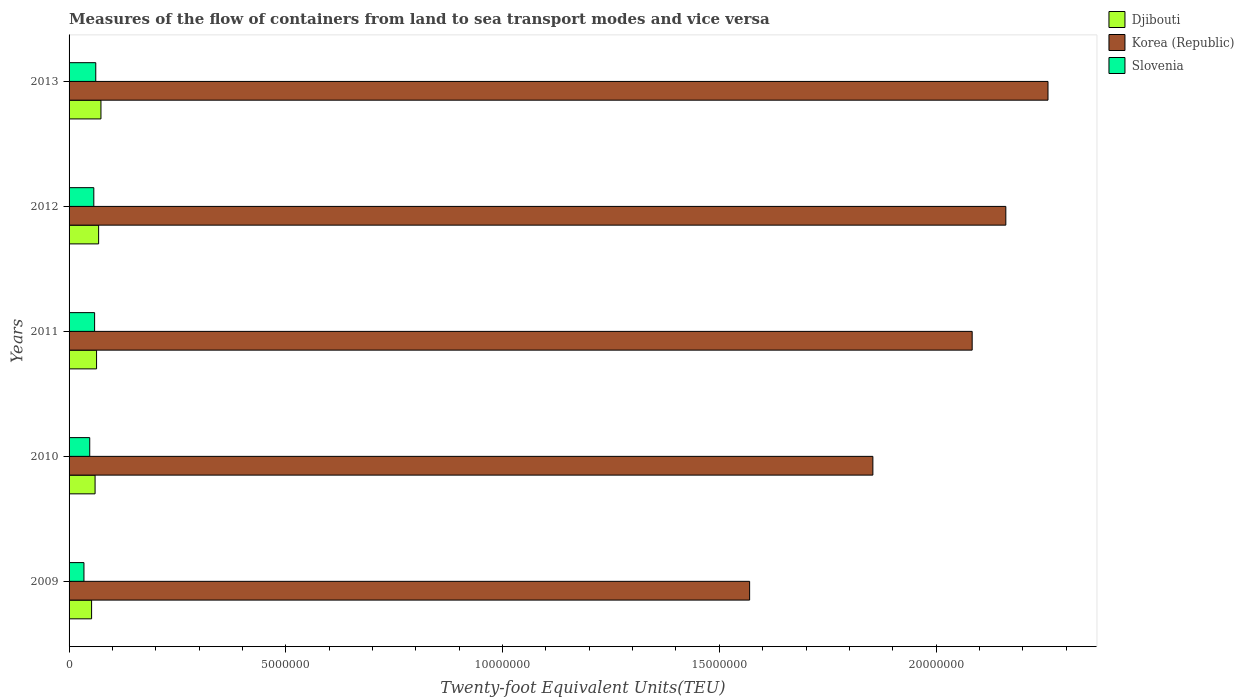How many different coloured bars are there?
Offer a very short reply. 3. How many groups of bars are there?
Your answer should be very brief. 5. How many bars are there on the 4th tick from the top?
Your answer should be compact. 3. How many bars are there on the 3rd tick from the bottom?
Your answer should be very brief. 3. What is the label of the 5th group of bars from the top?
Make the answer very short. 2009. What is the container port traffic in Djibouti in 2010?
Provide a short and direct response. 6.00e+05. Across all years, what is the maximum container port traffic in Slovenia?
Offer a terse response. 6.16e+05. Across all years, what is the minimum container port traffic in Korea (Republic)?
Offer a very short reply. 1.57e+07. What is the total container port traffic in Djibouti in the graph?
Provide a succinct answer. 3.17e+06. What is the difference between the container port traffic in Korea (Republic) in 2010 and that in 2011?
Provide a succinct answer. -2.29e+06. What is the difference between the container port traffic in Djibouti in 2010 and the container port traffic in Slovenia in 2009?
Make the answer very short. 2.57e+05. What is the average container port traffic in Djibouti per year?
Ensure brevity in your answer.  6.34e+05. In the year 2010, what is the difference between the container port traffic in Djibouti and container port traffic in Korea (Republic)?
Your answer should be very brief. -1.79e+07. What is the ratio of the container port traffic in Korea (Republic) in 2011 to that in 2012?
Provide a succinct answer. 0.96. What is the difference between the highest and the second highest container port traffic in Slovenia?
Give a very brief answer. 2.65e+04. What is the difference between the highest and the lowest container port traffic in Djibouti?
Offer a very short reply. 2.16e+05. In how many years, is the container port traffic in Slovenia greater than the average container port traffic in Slovenia taken over all years?
Keep it short and to the point. 3. What does the 2nd bar from the top in 2009 represents?
Provide a succinct answer. Korea (Republic). How many bars are there?
Offer a very short reply. 15. Where does the legend appear in the graph?
Provide a succinct answer. Top right. How many legend labels are there?
Your answer should be compact. 3. How are the legend labels stacked?
Ensure brevity in your answer.  Vertical. What is the title of the graph?
Your response must be concise. Measures of the flow of containers from land to sea transport modes and vice versa. What is the label or title of the X-axis?
Make the answer very short. Twenty-foot Equivalent Units(TEU). What is the label or title of the Y-axis?
Keep it short and to the point. Years. What is the Twenty-foot Equivalent Units(TEU) of Djibouti in 2009?
Your response must be concise. 5.20e+05. What is the Twenty-foot Equivalent Units(TEU) in Korea (Republic) in 2009?
Your response must be concise. 1.57e+07. What is the Twenty-foot Equivalent Units(TEU) of Slovenia in 2009?
Provide a succinct answer. 3.43e+05. What is the Twenty-foot Equivalent Units(TEU) of Djibouti in 2010?
Offer a terse response. 6.00e+05. What is the Twenty-foot Equivalent Units(TEU) of Korea (Republic) in 2010?
Offer a terse response. 1.85e+07. What is the Twenty-foot Equivalent Units(TEU) of Slovenia in 2010?
Ensure brevity in your answer.  4.77e+05. What is the Twenty-foot Equivalent Units(TEU) in Djibouti in 2011?
Make the answer very short. 6.34e+05. What is the Twenty-foot Equivalent Units(TEU) in Korea (Republic) in 2011?
Offer a very short reply. 2.08e+07. What is the Twenty-foot Equivalent Units(TEU) in Slovenia in 2011?
Offer a very short reply. 5.89e+05. What is the Twenty-foot Equivalent Units(TEU) of Djibouti in 2012?
Offer a terse response. 6.82e+05. What is the Twenty-foot Equivalent Units(TEU) of Korea (Republic) in 2012?
Offer a terse response. 2.16e+07. What is the Twenty-foot Equivalent Units(TEU) of Slovenia in 2012?
Offer a terse response. 5.71e+05. What is the Twenty-foot Equivalent Units(TEU) in Djibouti in 2013?
Give a very brief answer. 7.36e+05. What is the Twenty-foot Equivalent Units(TEU) of Korea (Republic) in 2013?
Your answer should be compact. 2.26e+07. What is the Twenty-foot Equivalent Units(TEU) of Slovenia in 2013?
Provide a succinct answer. 6.16e+05. Across all years, what is the maximum Twenty-foot Equivalent Units(TEU) in Djibouti?
Offer a very short reply. 7.36e+05. Across all years, what is the maximum Twenty-foot Equivalent Units(TEU) of Korea (Republic)?
Your answer should be very brief. 2.26e+07. Across all years, what is the maximum Twenty-foot Equivalent Units(TEU) of Slovenia?
Your answer should be compact. 6.16e+05. Across all years, what is the minimum Twenty-foot Equivalent Units(TEU) in Djibouti?
Make the answer very short. 5.20e+05. Across all years, what is the minimum Twenty-foot Equivalent Units(TEU) in Korea (Republic)?
Give a very brief answer. 1.57e+07. Across all years, what is the minimum Twenty-foot Equivalent Units(TEU) of Slovenia?
Offer a very short reply. 3.43e+05. What is the total Twenty-foot Equivalent Units(TEU) of Djibouti in the graph?
Offer a very short reply. 3.17e+06. What is the total Twenty-foot Equivalent Units(TEU) of Korea (Republic) in the graph?
Offer a very short reply. 9.93e+07. What is the total Twenty-foot Equivalent Units(TEU) in Slovenia in the graph?
Provide a short and direct response. 2.60e+06. What is the difference between the Twenty-foot Equivalent Units(TEU) in Djibouti in 2009 and that in 2010?
Give a very brief answer. -8.05e+04. What is the difference between the Twenty-foot Equivalent Units(TEU) of Korea (Republic) in 2009 and that in 2010?
Make the answer very short. -2.84e+06. What is the difference between the Twenty-foot Equivalent Units(TEU) in Slovenia in 2009 and that in 2010?
Make the answer very short. -1.34e+05. What is the difference between the Twenty-foot Equivalent Units(TEU) in Djibouti in 2009 and that in 2011?
Keep it short and to the point. -1.15e+05. What is the difference between the Twenty-foot Equivalent Units(TEU) in Korea (Republic) in 2009 and that in 2011?
Provide a short and direct response. -5.13e+06. What is the difference between the Twenty-foot Equivalent Units(TEU) in Slovenia in 2009 and that in 2011?
Your response must be concise. -2.46e+05. What is the difference between the Twenty-foot Equivalent Units(TEU) of Djibouti in 2009 and that in 2012?
Ensure brevity in your answer.  -1.62e+05. What is the difference between the Twenty-foot Equivalent Units(TEU) in Korea (Republic) in 2009 and that in 2012?
Offer a very short reply. -5.91e+06. What is the difference between the Twenty-foot Equivalent Units(TEU) of Slovenia in 2009 and that in 2012?
Make the answer very short. -2.28e+05. What is the difference between the Twenty-foot Equivalent Units(TEU) in Djibouti in 2009 and that in 2013?
Offer a very short reply. -2.16e+05. What is the difference between the Twenty-foot Equivalent Units(TEU) in Korea (Republic) in 2009 and that in 2013?
Provide a short and direct response. -6.88e+06. What is the difference between the Twenty-foot Equivalent Units(TEU) in Slovenia in 2009 and that in 2013?
Provide a succinct answer. -2.73e+05. What is the difference between the Twenty-foot Equivalent Units(TEU) of Djibouti in 2010 and that in 2011?
Ensure brevity in your answer.  -3.42e+04. What is the difference between the Twenty-foot Equivalent Units(TEU) of Korea (Republic) in 2010 and that in 2011?
Provide a succinct answer. -2.29e+06. What is the difference between the Twenty-foot Equivalent Units(TEU) in Slovenia in 2010 and that in 2011?
Provide a succinct answer. -1.13e+05. What is the difference between the Twenty-foot Equivalent Units(TEU) of Djibouti in 2010 and that in 2012?
Offer a terse response. -8.18e+04. What is the difference between the Twenty-foot Equivalent Units(TEU) of Korea (Republic) in 2010 and that in 2012?
Give a very brief answer. -3.07e+06. What is the difference between the Twenty-foot Equivalent Units(TEU) of Slovenia in 2010 and that in 2012?
Your answer should be compact. -9.40e+04. What is the difference between the Twenty-foot Equivalent Units(TEU) of Djibouti in 2010 and that in 2013?
Provide a short and direct response. -1.36e+05. What is the difference between the Twenty-foot Equivalent Units(TEU) in Korea (Republic) in 2010 and that in 2013?
Your answer should be compact. -4.04e+06. What is the difference between the Twenty-foot Equivalent Units(TEU) in Slovenia in 2010 and that in 2013?
Your answer should be compact. -1.39e+05. What is the difference between the Twenty-foot Equivalent Units(TEU) of Djibouti in 2011 and that in 2012?
Offer a very short reply. -4.76e+04. What is the difference between the Twenty-foot Equivalent Units(TEU) in Korea (Republic) in 2011 and that in 2012?
Provide a succinct answer. -7.76e+05. What is the difference between the Twenty-foot Equivalent Units(TEU) of Slovenia in 2011 and that in 2012?
Provide a succinct answer. 1.86e+04. What is the difference between the Twenty-foot Equivalent Units(TEU) in Djibouti in 2011 and that in 2013?
Ensure brevity in your answer.  -1.01e+05. What is the difference between the Twenty-foot Equivalent Units(TEU) in Korea (Republic) in 2011 and that in 2013?
Ensure brevity in your answer.  -1.75e+06. What is the difference between the Twenty-foot Equivalent Units(TEU) in Slovenia in 2011 and that in 2013?
Make the answer very short. -2.65e+04. What is the difference between the Twenty-foot Equivalent Units(TEU) in Djibouti in 2012 and that in 2013?
Provide a short and direct response. -5.39e+04. What is the difference between the Twenty-foot Equivalent Units(TEU) in Korea (Republic) in 2012 and that in 2013?
Your answer should be very brief. -9.73e+05. What is the difference between the Twenty-foot Equivalent Units(TEU) in Slovenia in 2012 and that in 2013?
Your answer should be compact. -4.51e+04. What is the difference between the Twenty-foot Equivalent Units(TEU) in Djibouti in 2009 and the Twenty-foot Equivalent Units(TEU) in Korea (Republic) in 2010?
Make the answer very short. -1.80e+07. What is the difference between the Twenty-foot Equivalent Units(TEU) of Djibouti in 2009 and the Twenty-foot Equivalent Units(TEU) of Slovenia in 2010?
Make the answer very short. 4.28e+04. What is the difference between the Twenty-foot Equivalent Units(TEU) in Korea (Republic) in 2009 and the Twenty-foot Equivalent Units(TEU) in Slovenia in 2010?
Your answer should be very brief. 1.52e+07. What is the difference between the Twenty-foot Equivalent Units(TEU) of Djibouti in 2009 and the Twenty-foot Equivalent Units(TEU) of Korea (Republic) in 2011?
Keep it short and to the point. -2.03e+07. What is the difference between the Twenty-foot Equivalent Units(TEU) in Djibouti in 2009 and the Twenty-foot Equivalent Units(TEU) in Slovenia in 2011?
Provide a short and direct response. -6.98e+04. What is the difference between the Twenty-foot Equivalent Units(TEU) in Korea (Republic) in 2009 and the Twenty-foot Equivalent Units(TEU) in Slovenia in 2011?
Your answer should be very brief. 1.51e+07. What is the difference between the Twenty-foot Equivalent Units(TEU) in Djibouti in 2009 and the Twenty-foot Equivalent Units(TEU) in Korea (Republic) in 2012?
Give a very brief answer. -2.11e+07. What is the difference between the Twenty-foot Equivalent Units(TEU) in Djibouti in 2009 and the Twenty-foot Equivalent Units(TEU) in Slovenia in 2012?
Your answer should be compact. -5.12e+04. What is the difference between the Twenty-foot Equivalent Units(TEU) of Korea (Republic) in 2009 and the Twenty-foot Equivalent Units(TEU) of Slovenia in 2012?
Keep it short and to the point. 1.51e+07. What is the difference between the Twenty-foot Equivalent Units(TEU) in Djibouti in 2009 and the Twenty-foot Equivalent Units(TEU) in Korea (Republic) in 2013?
Provide a short and direct response. -2.21e+07. What is the difference between the Twenty-foot Equivalent Units(TEU) in Djibouti in 2009 and the Twenty-foot Equivalent Units(TEU) in Slovenia in 2013?
Provide a succinct answer. -9.63e+04. What is the difference between the Twenty-foot Equivalent Units(TEU) of Korea (Republic) in 2009 and the Twenty-foot Equivalent Units(TEU) of Slovenia in 2013?
Offer a terse response. 1.51e+07. What is the difference between the Twenty-foot Equivalent Units(TEU) of Djibouti in 2010 and the Twenty-foot Equivalent Units(TEU) of Korea (Republic) in 2011?
Your response must be concise. -2.02e+07. What is the difference between the Twenty-foot Equivalent Units(TEU) in Djibouti in 2010 and the Twenty-foot Equivalent Units(TEU) in Slovenia in 2011?
Provide a succinct answer. 1.07e+04. What is the difference between the Twenty-foot Equivalent Units(TEU) of Korea (Republic) in 2010 and the Twenty-foot Equivalent Units(TEU) of Slovenia in 2011?
Offer a terse response. 1.80e+07. What is the difference between the Twenty-foot Equivalent Units(TEU) of Djibouti in 2010 and the Twenty-foot Equivalent Units(TEU) of Korea (Republic) in 2012?
Your answer should be compact. -2.10e+07. What is the difference between the Twenty-foot Equivalent Units(TEU) in Djibouti in 2010 and the Twenty-foot Equivalent Units(TEU) in Slovenia in 2012?
Your answer should be very brief. 2.93e+04. What is the difference between the Twenty-foot Equivalent Units(TEU) of Korea (Republic) in 2010 and the Twenty-foot Equivalent Units(TEU) of Slovenia in 2012?
Make the answer very short. 1.80e+07. What is the difference between the Twenty-foot Equivalent Units(TEU) of Djibouti in 2010 and the Twenty-foot Equivalent Units(TEU) of Korea (Republic) in 2013?
Your response must be concise. -2.20e+07. What is the difference between the Twenty-foot Equivalent Units(TEU) of Djibouti in 2010 and the Twenty-foot Equivalent Units(TEU) of Slovenia in 2013?
Make the answer very short. -1.58e+04. What is the difference between the Twenty-foot Equivalent Units(TEU) in Korea (Republic) in 2010 and the Twenty-foot Equivalent Units(TEU) in Slovenia in 2013?
Your answer should be very brief. 1.79e+07. What is the difference between the Twenty-foot Equivalent Units(TEU) of Djibouti in 2011 and the Twenty-foot Equivalent Units(TEU) of Korea (Republic) in 2012?
Provide a succinct answer. -2.10e+07. What is the difference between the Twenty-foot Equivalent Units(TEU) in Djibouti in 2011 and the Twenty-foot Equivalent Units(TEU) in Slovenia in 2012?
Offer a very short reply. 6.35e+04. What is the difference between the Twenty-foot Equivalent Units(TEU) of Korea (Republic) in 2011 and the Twenty-foot Equivalent Units(TEU) of Slovenia in 2012?
Provide a short and direct response. 2.03e+07. What is the difference between the Twenty-foot Equivalent Units(TEU) in Djibouti in 2011 and the Twenty-foot Equivalent Units(TEU) in Korea (Republic) in 2013?
Offer a terse response. -2.19e+07. What is the difference between the Twenty-foot Equivalent Units(TEU) in Djibouti in 2011 and the Twenty-foot Equivalent Units(TEU) in Slovenia in 2013?
Offer a terse response. 1.84e+04. What is the difference between the Twenty-foot Equivalent Units(TEU) in Korea (Republic) in 2011 and the Twenty-foot Equivalent Units(TEU) in Slovenia in 2013?
Offer a very short reply. 2.02e+07. What is the difference between the Twenty-foot Equivalent Units(TEU) in Djibouti in 2012 and the Twenty-foot Equivalent Units(TEU) in Korea (Republic) in 2013?
Keep it short and to the point. -2.19e+07. What is the difference between the Twenty-foot Equivalent Units(TEU) in Djibouti in 2012 and the Twenty-foot Equivalent Units(TEU) in Slovenia in 2013?
Offer a very short reply. 6.59e+04. What is the difference between the Twenty-foot Equivalent Units(TEU) of Korea (Republic) in 2012 and the Twenty-foot Equivalent Units(TEU) of Slovenia in 2013?
Provide a short and direct response. 2.10e+07. What is the average Twenty-foot Equivalent Units(TEU) of Djibouti per year?
Your answer should be very brief. 6.34e+05. What is the average Twenty-foot Equivalent Units(TEU) in Korea (Republic) per year?
Your answer should be compact. 1.99e+07. What is the average Twenty-foot Equivalent Units(TEU) of Slovenia per year?
Your answer should be compact. 5.19e+05. In the year 2009, what is the difference between the Twenty-foot Equivalent Units(TEU) in Djibouti and Twenty-foot Equivalent Units(TEU) in Korea (Republic)?
Offer a very short reply. -1.52e+07. In the year 2009, what is the difference between the Twenty-foot Equivalent Units(TEU) in Djibouti and Twenty-foot Equivalent Units(TEU) in Slovenia?
Your response must be concise. 1.76e+05. In the year 2009, what is the difference between the Twenty-foot Equivalent Units(TEU) of Korea (Republic) and Twenty-foot Equivalent Units(TEU) of Slovenia?
Offer a very short reply. 1.54e+07. In the year 2010, what is the difference between the Twenty-foot Equivalent Units(TEU) of Djibouti and Twenty-foot Equivalent Units(TEU) of Korea (Republic)?
Ensure brevity in your answer.  -1.79e+07. In the year 2010, what is the difference between the Twenty-foot Equivalent Units(TEU) in Djibouti and Twenty-foot Equivalent Units(TEU) in Slovenia?
Provide a succinct answer. 1.23e+05. In the year 2010, what is the difference between the Twenty-foot Equivalent Units(TEU) of Korea (Republic) and Twenty-foot Equivalent Units(TEU) of Slovenia?
Keep it short and to the point. 1.81e+07. In the year 2011, what is the difference between the Twenty-foot Equivalent Units(TEU) in Djibouti and Twenty-foot Equivalent Units(TEU) in Korea (Republic)?
Your response must be concise. -2.02e+07. In the year 2011, what is the difference between the Twenty-foot Equivalent Units(TEU) of Djibouti and Twenty-foot Equivalent Units(TEU) of Slovenia?
Give a very brief answer. 4.49e+04. In the year 2011, what is the difference between the Twenty-foot Equivalent Units(TEU) in Korea (Republic) and Twenty-foot Equivalent Units(TEU) in Slovenia?
Your answer should be compact. 2.02e+07. In the year 2012, what is the difference between the Twenty-foot Equivalent Units(TEU) in Djibouti and Twenty-foot Equivalent Units(TEU) in Korea (Republic)?
Your answer should be very brief. -2.09e+07. In the year 2012, what is the difference between the Twenty-foot Equivalent Units(TEU) in Djibouti and Twenty-foot Equivalent Units(TEU) in Slovenia?
Provide a short and direct response. 1.11e+05. In the year 2012, what is the difference between the Twenty-foot Equivalent Units(TEU) of Korea (Republic) and Twenty-foot Equivalent Units(TEU) of Slovenia?
Your answer should be very brief. 2.10e+07. In the year 2013, what is the difference between the Twenty-foot Equivalent Units(TEU) in Djibouti and Twenty-foot Equivalent Units(TEU) in Korea (Republic)?
Your response must be concise. -2.18e+07. In the year 2013, what is the difference between the Twenty-foot Equivalent Units(TEU) in Djibouti and Twenty-foot Equivalent Units(TEU) in Slovenia?
Your response must be concise. 1.20e+05. In the year 2013, what is the difference between the Twenty-foot Equivalent Units(TEU) in Korea (Republic) and Twenty-foot Equivalent Units(TEU) in Slovenia?
Give a very brief answer. 2.20e+07. What is the ratio of the Twenty-foot Equivalent Units(TEU) of Djibouti in 2009 to that in 2010?
Provide a short and direct response. 0.87. What is the ratio of the Twenty-foot Equivalent Units(TEU) in Korea (Republic) in 2009 to that in 2010?
Provide a succinct answer. 0.85. What is the ratio of the Twenty-foot Equivalent Units(TEU) in Slovenia in 2009 to that in 2010?
Offer a terse response. 0.72. What is the ratio of the Twenty-foot Equivalent Units(TEU) of Djibouti in 2009 to that in 2011?
Make the answer very short. 0.82. What is the ratio of the Twenty-foot Equivalent Units(TEU) of Korea (Republic) in 2009 to that in 2011?
Offer a very short reply. 0.75. What is the ratio of the Twenty-foot Equivalent Units(TEU) of Slovenia in 2009 to that in 2011?
Provide a short and direct response. 0.58. What is the ratio of the Twenty-foot Equivalent Units(TEU) in Djibouti in 2009 to that in 2012?
Provide a succinct answer. 0.76. What is the ratio of the Twenty-foot Equivalent Units(TEU) in Korea (Republic) in 2009 to that in 2012?
Offer a terse response. 0.73. What is the ratio of the Twenty-foot Equivalent Units(TEU) in Slovenia in 2009 to that in 2012?
Provide a short and direct response. 0.6. What is the ratio of the Twenty-foot Equivalent Units(TEU) of Djibouti in 2009 to that in 2013?
Provide a succinct answer. 0.71. What is the ratio of the Twenty-foot Equivalent Units(TEU) of Korea (Republic) in 2009 to that in 2013?
Give a very brief answer. 0.7. What is the ratio of the Twenty-foot Equivalent Units(TEU) in Slovenia in 2009 to that in 2013?
Keep it short and to the point. 0.56. What is the ratio of the Twenty-foot Equivalent Units(TEU) of Djibouti in 2010 to that in 2011?
Give a very brief answer. 0.95. What is the ratio of the Twenty-foot Equivalent Units(TEU) of Korea (Republic) in 2010 to that in 2011?
Make the answer very short. 0.89. What is the ratio of the Twenty-foot Equivalent Units(TEU) of Slovenia in 2010 to that in 2011?
Provide a succinct answer. 0.81. What is the ratio of the Twenty-foot Equivalent Units(TEU) of Djibouti in 2010 to that in 2012?
Your response must be concise. 0.88. What is the ratio of the Twenty-foot Equivalent Units(TEU) in Korea (Republic) in 2010 to that in 2012?
Ensure brevity in your answer.  0.86. What is the ratio of the Twenty-foot Equivalent Units(TEU) in Slovenia in 2010 to that in 2012?
Your answer should be very brief. 0.84. What is the ratio of the Twenty-foot Equivalent Units(TEU) in Djibouti in 2010 to that in 2013?
Make the answer very short. 0.82. What is the ratio of the Twenty-foot Equivalent Units(TEU) of Korea (Republic) in 2010 to that in 2013?
Your answer should be compact. 0.82. What is the ratio of the Twenty-foot Equivalent Units(TEU) in Slovenia in 2010 to that in 2013?
Make the answer very short. 0.77. What is the ratio of the Twenty-foot Equivalent Units(TEU) of Djibouti in 2011 to that in 2012?
Your answer should be compact. 0.93. What is the ratio of the Twenty-foot Equivalent Units(TEU) of Korea (Republic) in 2011 to that in 2012?
Your answer should be very brief. 0.96. What is the ratio of the Twenty-foot Equivalent Units(TEU) in Slovenia in 2011 to that in 2012?
Offer a very short reply. 1.03. What is the ratio of the Twenty-foot Equivalent Units(TEU) in Djibouti in 2011 to that in 2013?
Make the answer very short. 0.86. What is the ratio of the Twenty-foot Equivalent Units(TEU) of Korea (Republic) in 2011 to that in 2013?
Make the answer very short. 0.92. What is the ratio of the Twenty-foot Equivalent Units(TEU) of Slovenia in 2011 to that in 2013?
Offer a terse response. 0.96. What is the ratio of the Twenty-foot Equivalent Units(TEU) in Djibouti in 2012 to that in 2013?
Ensure brevity in your answer.  0.93. What is the ratio of the Twenty-foot Equivalent Units(TEU) in Korea (Republic) in 2012 to that in 2013?
Ensure brevity in your answer.  0.96. What is the ratio of the Twenty-foot Equivalent Units(TEU) of Slovenia in 2012 to that in 2013?
Make the answer very short. 0.93. What is the difference between the highest and the second highest Twenty-foot Equivalent Units(TEU) in Djibouti?
Your response must be concise. 5.39e+04. What is the difference between the highest and the second highest Twenty-foot Equivalent Units(TEU) of Korea (Republic)?
Keep it short and to the point. 9.73e+05. What is the difference between the highest and the second highest Twenty-foot Equivalent Units(TEU) of Slovenia?
Your answer should be very brief. 2.65e+04. What is the difference between the highest and the lowest Twenty-foot Equivalent Units(TEU) of Djibouti?
Keep it short and to the point. 2.16e+05. What is the difference between the highest and the lowest Twenty-foot Equivalent Units(TEU) of Korea (Republic)?
Ensure brevity in your answer.  6.88e+06. What is the difference between the highest and the lowest Twenty-foot Equivalent Units(TEU) of Slovenia?
Provide a short and direct response. 2.73e+05. 